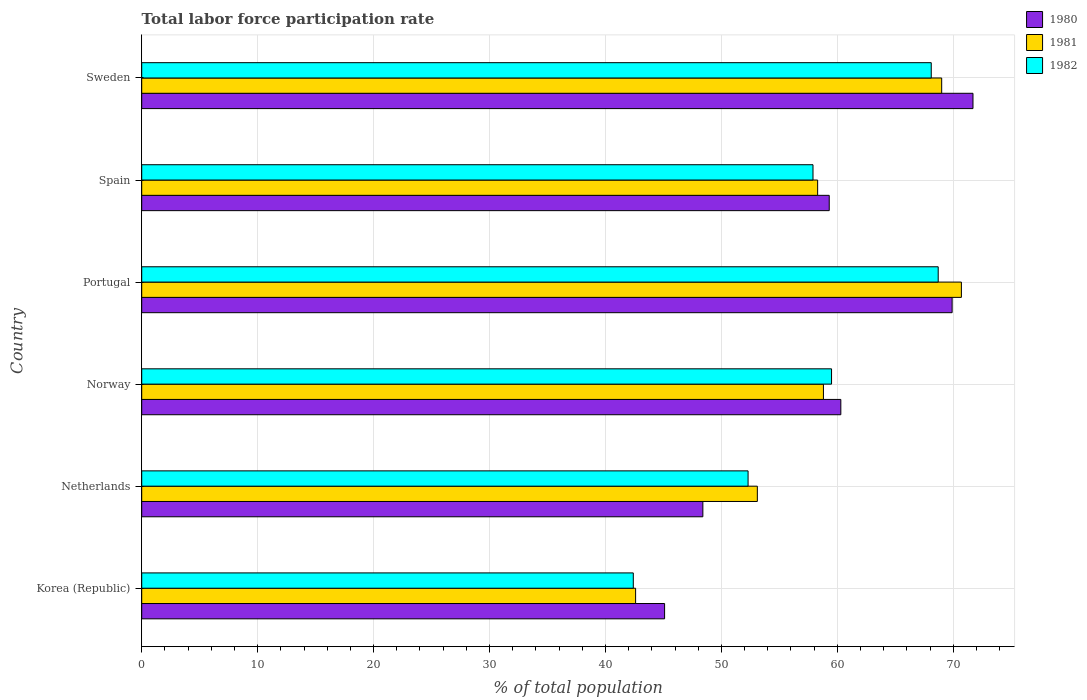How many groups of bars are there?
Make the answer very short. 6. Are the number of bars per tick equal to the number of legend labels?
Offer a very short reply. Yes. Are the number of bars on each tick of the Y-axis equal?
Your response must be concise. Yes. How many bars are there on the 4th tick from the bottom?
Your answer should be very brief. 3. What is the label of the 6th group of bars from the top?
Ensure brevity in your answer.  Korea (Republic). What is the total labor force participation rate in 1982 in Portugal?
Your response must be concise. 68.7. Across all countries, what is the maximum total labor force participation rate in 1982?
Your answer should be compact. 68.7. Across all countries, what is the minimum total labor force participation rate in 1981?
Ensure brevity in your answer.  42.6. What is the total total labor force participation rate in 1982 in the graph?
Your answer should be compact. 348.9. What is the difference between the total labor force participation rate in 1981 in Netherlands and that in Sweden?
Your answer should be compact. -15.9. What is the difference between the total labor force participation rate in 1980 in Portugal and the total labor force participation rate in 1982 in Korea (Republic)?
Your answer should be compact. 27.5. What is the average total labor force participation rate in 1982 per country?
Ensure brevity in your answer.  58.15. What is the difference between the total labor force participation rate in 1981 and total labor force participation rate in 1980 in Sweden?
Your response must be concise. -2.7. In how many countries, is the total labor force participation rate in 1982 greater than 42 %?
Provide a succinct answer. 6. What is the ratio of the total labor force participation rate in 1980 in Netherlands to that in Norway?
Ensure brevity in your answer.  0.8. What is the difference between the highest and the second highest total labor force participation rate in 1980?
Keep it short and to the point. 1.8. What is the difference between the highest and the lowest total labor force participation rate in 1981?
Give a very brief answer. 28.1. In how many countries, is the total labor force participation rate in 1982 greater than the average total labor force participation rate in 1982 taken over all countries?
Offer a very short reply. 3. What does the 1st bar from the top in Korea (Republic) represents?
Keep it short and to the point. 1982. What does the 3rd bar from the bottom in Sweden represents?
Your answer should be very brief. 1982. Is it the case that in every country, the sum of the total labor force participation rate in 1980 and total labor force participation rate in 1981 is greater than the total labor force participation rate in 1982?
Ensure brevity in your answer.  Yes. How many bars are there?
Make the answer very short. 18. How many countries are there in the graph?
Your answer should be compact. 6. Are the values on the major ticks of X-axis written in scientific E-notation?
Offer a very short reply. No. How are the legend labels stacked?
Offer a very short reply. Vertical. What is the title of the graph?
Provide a short and direct response. Total labor force participation rate. Does "2000" appear as one of the legend labels in the graph?
Keep it short and to the point. No. What is the label or title of the X-axis?
Provide a succinct answer. % of total population. What is the % of total population in 1980 in Korea (Republic)?
Provide a succinct answer. 45.1. What is the % of total population in 1981 in Korea (Republic)?
Make the answer very short. 42.6. What is the % of total population in 1982 in Korea (Republic)?
Make the answer very short. 42.4. What is the % of total population of 1980 in Netherlands?
Keep it short and to the point. 48.4. What is the % of total population in 1981 in Netherlands?
Ensure brevity in your answer.  53.1. What is the % of total population of 1982 in Netherlands?
Provide a short and direct response. 52.3. What is the % of total population of 1980 in Norway?
Offer a very short reply. 60.3. What is the % of total population in 1981 in Norway?
Provide a succinct answer. 58.8. What is the % of total population in 1982 in Norway?
Provide a succinct answer. 59.5. What is the % of total population of 1980 in Portugal?
Give a very brief answer. 69.9. What is the % of total population in 1981 in Portugal?
Offer a terse response. 70.7. What is the % of total population in 1982 in Portugal?
Provide a short and direct response. 68.7. What is the % of total population in 1980 in Spain?
Keep it short and to the point. 59.3. What is the % of total population of 1981 in Spain?
Make the answer very short. 58.3. What is the % of total population of 1982 in Spain?
Provide a succinct answer. 57.9. What is the % of total population in 1980 in Sweden?
Keep it short and to the point. 71.7. What is the % of total population of 1981 in Sweden?
Your answer should be compact. 69. What is the % of total population of 1982 in Sweden?
Your answer should be very brief. 68.1. Across all countries, what is the maximum % of total population of 1980?
Make the answer very short. 71.7. Across all countries, what is the maximum % of total population of 1981?
Your response must be concise. 70.7. Across all countries, what is the maximum % of total population of 1982?
Offer a terse response. 68.7. Across all countries, what is the minimum % of total population of 1980?
Ensure brevity in your answer.  45.1. Across all countries, what is the minimum % of total population of 1981?
Offer a very short reply. 42.6. Across all countries, what is the minimum % of total population in 1982?
Offer a terse response. 42.4. What is the total % of total population of 1980 in the graph?
Keep it short and to the point. 354.7. What is the total % of total population in 1981 in the graph?
Provide a short and direct response. 352.5. What is the total % of total population of 1982 in the graph?
Your answer should be very brief. 348.9. What is the difference between the % of total population in 1980 in Korea (Republic) and that in Netherlands?
Provide a succinct answer. -3.3. What is the difference between the % of total population in 1981 in Korea (Republic) and that in Netherlands?
Keep it short and to the point. -10.5. What is the difference between the % of total population of 1980 in Korea (Republic) and that in Norway?
Make the answer very short. -15.2. What is the difference between the % of total population in 1981 in Korea (Republic) and that in Norway?
Keep it short and to the point. -16.2. What is the difference between the % of total population of 1982 in Korea (Republic) and that in Norway?
Your answer should be compact. -17.1. What is the difference between the % of total population of 1980 in Korea (Republic) and that in Portugal?
Keep it short and to the point. -24.8. What is the difference between the % of total population in 1981 in Korea (Republic) and that in Portugal?
Give a very brief answer. -28.1. What is the difference between the % of total population of 1982 in Korea (Republic) and that in Portugal?
Your response must be concise. -26.3. What is the difference between the % of total population in 1980 in Korea (Republic) and that in Spain?
Offer a very short reply. -14.2. What is the difference between the % of total population of 1981 in Korea (Republic) and that in Spain?
Make the answer very short. -15.7. What is the difference between the % of total population in 1982 in Korea (Republic) and that in Spain?
Your answer should be very brief. -15.5. What is the difference between the % of total population of 1980 in Korea (Republic) and that in Sweden?
Your answer should be very brief. -26.6. What is the difference between the % of total population of 1981 in Korea (Republic) and that in Sweden?
Offer a very short reply. -26.4. What is the difference between the % of total population in 1982 in Korea (Republic) and that in Sweden?
Your answer should be very brief. -25.7. What is the difference between the % of total population of 1980 in Netherlands and that in Norway?
Provide a short and direct response. -11.9. What is the difference between the % of total population in 1982 in Netherlands and that in Norway?
Make the answer very short. -7.2. What is the difference between the % of total population in 1980 in Netherlands and that in Portugal?
Keep it short and to the point. -21.5. What is the difference between the % of total population in 1981 in Netherlands and that in Portugal?
Give a very brief answer. -17.6. What is the difference between the % of total population in 1982 in Netherlands and that in Portugal?
Offer a very short reply. -16.4. What is the difference between the % of total population in 1982 in Netherlands and that in Spain?
Provide a succinct answer. -5.6. What is the difference between the % of total population of 1980 in Netherlands and that in Sweden?
Provide a succinct answer. -23.3. What is the difference between the % of total population in 1981 in Netherlands and that in Sweden?
Provide a short and direct response. -15.9. What is the difference between the % of total population in 1982 in Netherlands and that in Sweden?
Your response must be concise. -15.8. What is the difference between the % of total population of 1981 in Norway and that in Portugal?
Ensure brevity in your answer.  -11.9. What is the difference between the % of total population in 1982 in Norway and that in Portugal?
Give a very brief answer. -9.2. What is the difference between the % of total population in 1980 in Norway and that in Spain?
Your answer should be very brief. 1. What is the difference between the % of total population in 1981 in Norway and that in Spain?
Provide a short and direct response. 0.5. What is the difference between the % of total population of 1982 in Norway and that in Spain?
Your response must be concise. 1.6. What is the difference between the % of total population in 1981 in Norway and that in Sweden?
Offer a terse response. -10.2. What is the difference between the % of total population in 1982 in Norway and that in Sweden?
Give a very brief answer. -8.6. What is the difference between the % of total population of 1980 in Portugal and that in Spain?
Offer a terse response. 10.6. What is the difference between the % of total population in 1981 in Portugal and that in Sweden?
Offer a terse response. 1.7. What is the difference between the % of total population in 1982 in Portugal and that in Sweden?
Make the answer very short. 0.6. What is the difference between the % of total population in 1981 in Spain and that in Sweden?
Your answer should be very brief. -10.7. What is the difference between the % of total population of 1980 in Korea (Republic) and the % of total population of 1982 in Netherlands?
Keep it short and to the point. -7.2. What is the difference between the % of total population in 1981 in Korea (Republic) and the % of total population in 1982 in Netherlands?
Offer a very short reply. -9.7. What is the difference between the % of total population of 1980 in Korea (Republic) and the % of total population of 1981 in Norway?
Provide a succinct answer. -13.7. What is the difference between the % of total population of 1980 in Korea (Republic) and the % of total population of 1982 in Norway?
Give a very brief answer. -14.4. What is the difference between the % of total population of 1981 in Korea (Republic) and the % of total population of 1982 in Norway?
Offer a very short reply. -16.9. What is the difference between the % of total population of 1980 in Korea (Republic) and the % of total population of 1981 in Portugal?
Provide a short and direct response. -25.6. What is the difference between the % of total population in 1980 in Korea (Republic) and the % of total population in 1982 in Portugal?
Your answer should be compact. -23.6. What is the difference between the % of total population in 1981 in Korea (Republic) and the % of total population in 1982 in Portugal?
Provide a succinct answer. -26.1. What is the difference between the % of total population of 1980 in Korea (Republic) and the % of total population of 1982 in Spain?
Offer a terse response. -12.8. What is the difference between the % of total population of 1981 in Korea (Republic) and the % of total population of 1982 in Spain?
Provide a short and direct response. -15.3. What is the difference between the % of total population in 1980 in Korea (Republic) and the % of total population in 1981 in Sweden?
Your answer should be very brief. -23.9. What is the difference between the % of total population of 1981 in Korea (Republic) and the % of total population of 1982 in Sweden?
Give a very brief answer. -25.5. What is the difference between the % of total population of 1980 in Netherlands and the % of total population of 1981 in Norway?
Your answer should be very brief. -10.4. What is the difference between the % of total population of 1980 in Netherlands and the % of total population of 1982 in Norway?
Make the answer very short. -11.1. What is the difference between the % of total population in 1981 in Netherlands and the % of total population in 1982 in Norway?
Ensure brevity in your answer.  -6.4. What is the difference between the % of total population in 1980 in Netherlands and the % of total population in 1981 in Portugal?
Your answer should be very brief. -22.3. What is the difference between the % of total population of 1980 in Netherlands and the % of total population of 1982 in Portugal?
Your answer should be very brief. -20.3. What is the difference between the % of total population of 1981 in Netherlands and the % of total population of 1982 in Portugal?
Ensure brevity in your answer.  -15.6. What is the difference between the % of total population of 1980 in Netherlands and the % of total population of 1982 in Spain?
Offer a very short reply. -9.5. What is the difference between the % of total population of 1981 in Netherlands and the % of total population of 1982 in Spain?
Ensure brevity in your answer.  -4.8. What is the difference between the % of total population in 1980 in Netherlands and the % of total population in 1981 in Sweden?
Ensure brevity in your answer.  -20.6. What is the difference between the % of total population in 1980 in Netherlands and the % of total population in 1982 in Sweden?
Offer a terse response. -19.7. What is the difference between the % of total population in 1981 in Netherlands and the % of total population in 1982 in Sweden?
Your response must be concise. -15. What is the difference between the % of total population in 1980 in Norway and the % of total population in 1981 in Portugal?
Offer a terse response. -10.4. What is the difference between the % of total population in 1980 in Norway and the % of total population in 1982 in Portugal?
Ensure brevity in your answer.  -8.4. What is the difference between the % of total population of 1980 in Norway and the % of total population of 1981 in Spain?
Provide a short and direct response. 2. What is the difference between the % of total population in 1980 in Norway and the % of total population in 1982 in Spain?
Keep it short and to the point. 2.4. What is the difference between the % of total population of 1981 in Norway and the % of total population of 1982 in Spain?
Provide a short and direct response. 0.9. What is the difference between the % of total population of 1980 in Norway and the % of total population of 1981 in Sweden?
Offer a very short reply. -8.7. What is the difference between the % of total population in 1981 in Norway and the % of total population in 1982 in Sweden?
Your answer should be compact. -9.3. What is the difference between the % of total population of 1980 in Portugal and the % of total population of 1982 in Spain?
Your answer should be compact. 12. What is the difference between the % of total population of 1980 in Portugal and the % of total population of 1981 in Sweden?
Provide a succinct answer. 0.9. What is the difference between the % of total population in 1980 in Portugal and the % of total population in 1982 in Sweden?
Provide a succinct answer. 1.8. What is the difference between the % of total population in 1981 in Portugal and the % of total population in 1982 in Sweden?
Your answer should be very brief. 2.6. What is the difference between the % of total population in 1980 in Spain and the % of total population in 1982 in Sweden?
Your response must be concise. -8.8. What is the difference between the % of total population in 1981 in Spain and the % of total population in 1982 in Sweden?
Provide a short and direct response. -9.8. What is the average % of total population of 1980 per country?
Keep it short and to the point. 59.12. What is the average % of total population in 1981 per country?
Your answer should be compact. 58.75. What is the average % of total population of 1982 per country?
Offer a very short reply. 58.15. What is the difference between the % of total population of 1980 and % of total population of 1981 in Korea (Republic)?
Give a very brief answer. 2.5. What is the difference between the % of total population of 1980 and % of total population of 1982 in Korea (Republic)?
Ensure brevity in your answer.  2.7. What is the difference between the % of total population in 1981 and % of total population in 1982 in Korea (Republic)?
Your answer should be compact. 0.2. What is the difference between the % of total population of 1980 and % of total population of 1982 in Netherlands?
Provide a short and direct response. -3.9. What is the difference between the % of total population of 1980 and % of total population of 1982 in Norway?
Provide a short and direct response. 0.8. What is the difference between the % of total population in 1981 and % of total population in 1982 in Norway?
Keep it short and to the point. -0.7. What is the difference between the % of total population in 1980 and % of total population in 1981 in Spain?
Your answer should be very brief. 1. What is the difference between the % of total population of 1980 and % of total population of 1982 in Spain?
Provide a short and direct response. 1.4. What is the difference between the % of total population in 1981 and % of total population in 1982 in Spain?
Keep it short and to the point. 0.4. What is the ratio of the % of total population of 1980 in Korea (Republic) to that in Netherlands?
Your response must be concise. 0.93. What is the ratio of the % of total population of 1981 in Korea (Republic) to that in Netherlands?
Offer a very short reply. 0.8. What is the ratio of the % of total population in 1982 in Korea (Republic) to that in Netherlands?
Provide a short and direct response. 0.81. What is the ratio of the % of total population in 1980 in Korea (Republic) to that in Norway?
Your answer should be compact. 0.75. What is the ratio of the % of total population in 1981 in Korea (Republic) to that in Norway?
Provide a short and direct response. 0.72. What is the ratio of the % of total population in 1982 in Korea (Republic) to that in Norway?
Give a very brief answer. 0.71. What is the ratio of the % of total population in 1980 in Korea (Republic) to that in Portugal?
Your answer should be compact. 0.65. What is the ratio of the % of total population of 1981 in Korea (Republic) to that in Portugal?
Give a very brief answer. 0.6. What is the ratio of the % of total population of 1982 in Korea (Republic) to that in Portugal?
Ensure brevity in your answer.  0.62. What is the ratio of the % of total population of 1980 in Korea (Republic) to that in Spain?
Provide a short and direct response. 0.76. What is the ratio of the % of total population of 1981 in Korea (Republic) to that in Spain?
Give a very brief answer. 0.73. What is the ratio of the % of total population of 1982 in Korea (Republic) to that in Spain?
Offer a terse response. 0.73. What is the ratio of the % of total population of 1980 in Korea (Republic) to that in Sweden?
Make the answer very short. 0.63. What is the ratio of the % of total population of 1981 in Korea (Republic) to that in Sweden?
Offer a very short reply. 0.62. What is the ratio of the % of total population in 1982 in Korea (Republic) to that in Sweden?
Your answer should be very brief. 0.62. What is the ratio of the % of total population of 1980 in Netherlands to that in Norway?
Offer a terse response. 0.8. What is the ratio of the % of total population of 1981 in Netherlands to that in Norway?
Offer a terse response. 0.9. What is the ratio of the % of total population in 1982 in Netherlands to that in Norway?
Your response must be concise. 0.88. What is the ratio of the % of total population of 1980 in Netherlands to that in Portugal?
Provide a short and direct response. 0.69. What is the ratio of the % of total population in 1981 in Netherlands to that in Portugal?
Give a very brief answer. 0.75. What is the ratio of the % of total population of 1982 in Netherlands to that in Portugal?
Keep it short and to the point. 0.76. What is the ratio of the % of total population of 1980 in Netherlands to that in Spain?
Your answer should be very brief. 0.82. What is the ratio of the % of total population of 1981 in Netherlands to that in Spain?
Keep it short and to the point. 0.91. What is the ratio of the % of total population of 1982 in Netherlands to that in Spain?
Make the answer very short. 0.9. What is the ratio of the % of total population of 1980 in Netherlands to that in Sweden?
Offer a terse response. 0.68. What is the ratio of the % of total population in 1981 in Netherlands to that in Sweden?
Ensure brevity in your answer.  0.77. What is the ratio of the % of total population of 1982 in Netherlands to that in Sweden?
Your answer should be very brief. 0.77. What is the ratio of the % of total population in 1980 in Norway to that in Portugal?
Keep it short and to the point. 0.86. What is the ratio of the % of total population in 1981 in Norway to that in Portugal?
Your response must be concise. 0.83. What is the ratio of the % of total population of 1982 in Norway to that in Portugal?
Offer a very short reply. 0.87. What is the ratio of the % of total population in 1980 in Norway to that in Spain?
Keep it short and to the point. 1.02. What is the ratio of the % of total population in 1981 in Norway to that in Spain?
Provide a succinct answer. 1.01. What is the ratio of the % of total population in 1982 in Norway to that in Spain?
Your answer should be very brief. 1.03. What is the ratio of the % of total population of 1980 in Norway to that in Sweden?
Provide a short and direct response. 0.84. What is the ratio of the % of total population in 1981 in Norway to that in Sweden?
Give a very brief answer. 0.85. What is the ratio of the % of total population of 1982 in Norway to that in Sweden?
Your answer should be compact. 0.87. What is the ratio of the % of total population of 1980 in Portugal to that in Spain?
Offer a very short reply. 1.18. What is the ratio of the % of total population of 1981 in Portugal to that in Spain?
Provide a succinct answer. 1.21. What is the ratio of the % of total population in 1982 in Portugal to that in Spain?
Provide a succinct answer. 1.19. What is the ratio of the % of total population in 1980 in Portugal to that in Sweden?
Give a very brief answer. 0.97. What is the ratio of the % of total population in 1981 in Portugal to that in Sweden?
Offer a very short reply. 1.02. What is the ratio of the % of total population in 1982 in Portugal to that in Sweden?
Provide a succinct answer. 1.01. What is the ratio of the % of total population of 1980 in Spain to that in Sweden?
Your response must be concise. 0.83. What is the ratio of the % of total population of 1981 in Spain to that in Sweden?
Provide a short and direct response. 0.84. What is the ratio of the % of total population in 1982 in Spain to that in Sweden?
Offer a very short reply. 0.85. What is the difference between the highest and the second highest % of total population in 1980?
Ensure brevity in your answer.  1.8. What is the difference between the highest and the second highest % of total population of 1981?
Your answer should be compact. 1.7. What is the difference between the highest and the second highest % of total population of 1982?
Make the answer very short. 0.6. What is the difference between the highest and the lowest % of total population in 1980?
Your response must be concise. 26.6. What is the difference between the highest and the lowest % of total population of 1981?
Provide a short and direct response. 28.1. What is the difference between the highest and the lowest % of total population in 1982?
Ensure brevity in your answer.  26.3. 